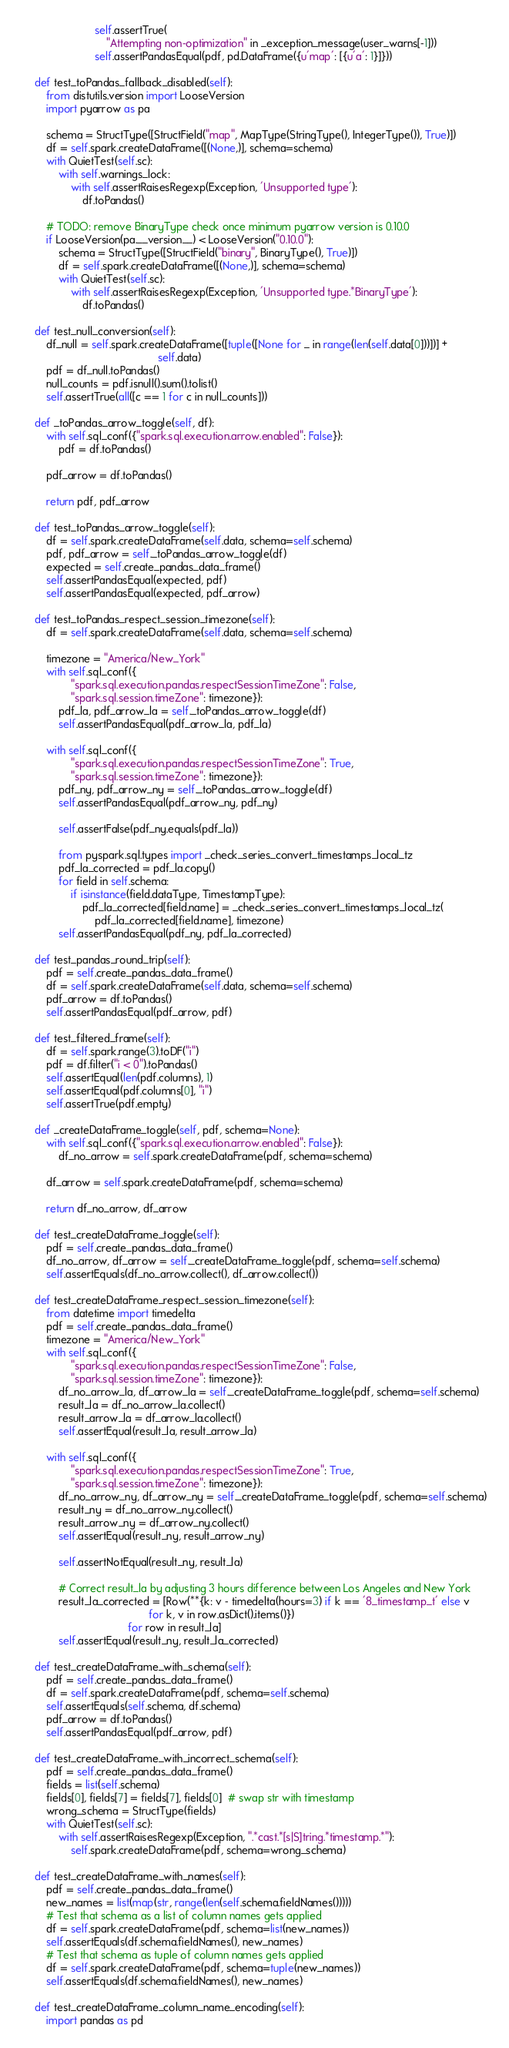<code> <loc_0><loc_0><loc_500><loc_500><_Python_>                        self.assertTrue(
                            "Attempting non-optimization" in _exception_message(user_warns[-1]))
                        self.assertPandasEqual(pdf, pd.DataFrame({u'map': [{u'a': 1}]}))

    def test_toPandas_fallback_disabled(self):
        from distutils.version import LooseVersion
        import pyarrow as pa

        schema = StructType([StructField("map", MapType(StringType(), IntegerType()), True)])
        df = self.spark.createDataFrame([(None,)], schema=schema)
        with QuietTest(self.sc):
            with self.warnings_lock:
                with self.assertRaisesRegexp(Exception, 'Unsupported type'):
                    df.toPandas()

        # TODO: remove BinaryType check once minimum pyarrow version is 0.10.0
        if LooseVersion(pa.__version__) < LooseVersion("0.10.0"):
            schema = StructType([StructField("binary", BinaryType(), True)])
            df = self.spark.createDataFrame([(None,)], schema=schema)
            with QuietTest(self.sc):
                with self.assertRaisesRegexp(Exception, 'Unsupported type.*BinaryType'):
                    df.toPandas()

    def test_null_conversion(self):
        df_null = self.spark.createDataFrame([tuple([None for _ in range(len(self.data[0]))])] +
                                             self.data)
        pdf = df_null.toPandas()
        null_counts = pdf.isnull().sum().tolist()
        self.assertTrue(all([c == 1 for c in null_counts]))

    def _toPandas_arrow_toggle(self, df):
        with self.sql_conf({"spark.sql.execution.arrow.enabled": False}):
            pdf = df.toPandas()

        pdf_arrow = df.toPandas()

        return pdf, pdf_arrow

    def test_toPandas_arrow_toggle(self):
        df = self.spark.createDataFrame(self.data, schema=self.schema)
        pdf, pdf_arrow = self._toPandas_arrow_toggle(df)
        expected = self.create_pandas_data_frame()
        self.assertPandasEqual(expected, pdf)
        self.assertPandasEqual(expected, pdf_arrow)

    def test_toPandas_respect_session_timezone(self):
        df = self.spark.createDataFrame(self.data, schema=self.schema)

        timezone = "America/New_York"
        with self.sql_conf({
                "spark.sql.execution.pandas.respectSessionTimeZone": False,
                "spark.sql.session.timeZone": timezone}):
            pdf_la, pdf_arrow_la = self._toPandas_arrow_toggle(df)
            self.assertPandasEqual(pdf_arrow_la, pdf_la)

        with self.sql_conf({
                "spark.sql.execution.pandas.respectSessionTimeZone": True,
                "spark.sql.session.timeZone": timezone}):
            pdf_ny, pdf_arrow_ny = self._toPandas_arrow_toggle(df)
            self.assertPandasEqual(pdf_arrow_ny, pdf_ny)

            self.assertFalse(pdf_ny.equals(pdf_la))

            from pyspark.sql.types import _check_series_convert_timestamps_local_tz
            pdf_la_corrected = pdf_la.copy()
            for field in self.schema:
                if isinstance(field.dataType, TimestampType):
                    pdf_la_corrected[field.name] = _check_series_convert_timestamps_local_tz(
                        pdf_la_corrected[field.name], timezone)
            self.assertPandasEqual(pdf_ny, pdf_la_corrected)

    def test_pandas_round_trip(self):
        pdf = self.create_pandas_data_frame()
        df = self.spark.createDataFrame(self.data, schema=self.schema)
        pdf_arrow = df.toPandas()
        self.assertPandasEqual(pdf_arrow, pdf)

    def test_filtered_frame(self):
        df = self.spark.range(3).toDF("i")
        pdf = df.filter("i < 0").toPandas()
        self.assertEqual(len(pdf.columns), 1)
        self.assertEqual(pdf.columns[0], "i")
        self.assertTrue(pdf.empty)

    def _createDataFrame_toggle(self, pdf, schema=None):
        with self.sql_conf({"spark.sql.execution.arrow.enabled": False}):
            df_no_arrow = self.spark.createDataFrame(pdf, schema=schema)

        df_arrow = self.spark.createDataFrame(pdf, schema=schema)

        return df_no_arrow, df_arrow

    def test_createDataFrame_toggle(self):
        pdf = self.create_pandas_data_frame()
        df_no_arrow, df_arrow = self._createDataFrame_toggle(pdf, schema=self.schema)
        self.assertEquals(df_no_arrow.collect(), df_arrow.collect())

    def test_createDataFrame_respect_session_timezone(self):
        from datetime import timedelta
        pdf = self.create_pandas_data_frame()
        timezone = "America/New_York"
        with self.sql_conf({
                "spark.sql.execution.pandas.respectSessionTimeZone": False,
                "spark.sql.session.timeZone": timezone}):
            df_no_arrow_la, df_arrow_la = self._createDataFrame_toggle(pdf, schema=self.schema)
            result_la = df_no_arrow_la.collect()
            result_arrow_la = df_arrow_la.collect()
            self.assertEqual(result_la, result_arrow_la)

        with self.sql_conf({
                "spark.sql.execution.pandas.respectSessionTimeZone": True,
                "spark.sql.session.timeZone": timezone}):
            df_no_arrow_ny, df_arrow_ny = self._createDataFrame_toggle(pdf, schema=self.schema)
            result_ny = df_no_arrow_ny.collect()
            result_arrow_ny = df_arrow_ny.collect()
            self.assertEqual(result_ny, result_arrow_ny)

            self.assertNotEqual(result_ny, result_la)

            # Correct result_la by adjusting 3 hours difference between Los Angeles and New York
            result_la_corrected = [Row(**{k: v - timedelta(hours=3) if k == '8_timestamp_t' else v
                                          for k, v in row.asDict().items()})
                                   for row in result_la]
            self.assertEqual(result_ny, result_la_corrected)

    def test_createDataFrame_with_schema(self):
        pdf = self.create_pandas_data_frame()
        df = self.spark.createDataFrame(pdf, schema=self.schema)
        self.assertEquals(self.schema, df.schema)
        pdf_arrow = df.toPandas()
        self.assertPandasEqual(pdf_arrow, pdf)

    def test_createDataFrame_with_incorrect_schema(self):
        pdf = self.create_pandas_data_frame()
        fields = list(self.schema)
        fields[0], fields[7] = fields[7], fields[0]  # swap str with timestamp
        wrong_schema = StructType(fields)
        with QuietTest(self.sc):
            with self.assertRaisesRegexp(Exception, ".*cast.*[s|S]tring.*timestamp.*"):
                self.spark.createDataFrame(pdf, schema=wrong_schema)

    def test_createDataFrame_with_names(self):
        pdf = self.create_pandas_data_frame()
        new_names = list(map(str, range(len(self.schema.fieldNames()))))
        # Test that schema as a list of column names gets applied
        df = self.spark.createDataFrame(pdf, schema=list(new_names))
        self.assertEquals(df.schema.fieldNames(), new_names)
        # Test that schema as tuple of column names gets applied
        df = self.spark.createDataFrame(pdf, schema=tuple(new_names))
        self.assertEquals(df.schema.fieldNames(), new_names)

    def test_createDataFrame_column_name_encoding(self):
        import pandas as pd</code> 